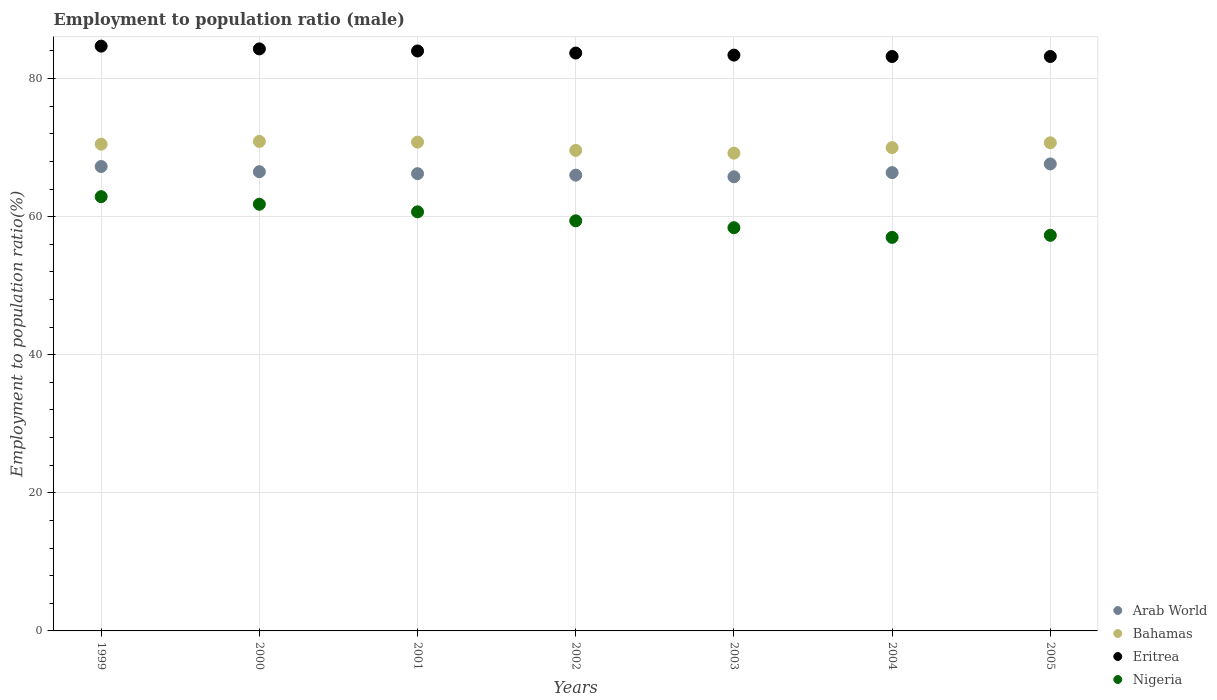Is the number of dotlines equal to the number of legend labels?
Keep it short and to the point. Yes. What is the employment to population ratio in Eritrea in 2002?
Provide a succinct answer. 83.7. Across all years, what is the maximum employment to population ratio in Eritrea?
Your answer should be compact. 84.7. Across all years, what is the minimum employment to population ratio in Arab World?
Provide a succinct answer. 65.78. What is the total employment to population ratio in Bahamas in the graph?
Keep it short and to the point. 491.7. What is the difference between the employment to population ratio in Bahamas in 2000 and that in 2004?
Offer a very short reply. 0.9. What is the difference between the employment to population ratio in Arab World in 2003 and the employment to population ratio in Bahamas in 2005?
Offer a terse response. -4.92. What is the average employment to population ratio in Nigeria per year?
Your response must be concise. 59.64. In the year 2002, what is the difference between the employment to population ratio in Arab World and employment to population ratio in Nigeria?
Your answer should be compact. 6.62. In how many years, is the employment to population ratio in Arab World greater than 48 %?
Provide a short and direct response. 7. What is the ratio of the employment to population ratio in Bahamas in 2001 to that in 2002?
Keep it short and to the point. 1.02. What is the difference between the highest and the second highest employment to population ratio in Arab World?
Provide a short and direct response. 0.37. What is the difference between the highest and the lowest employment to population ratio in Nigeria?
Offer a very short reply. 5.9. In how many years, is the employment to population ratio in Nigeria greater than the average employment to population ratio in Nigeria taken over all years?
Your response must be concise. 3. Is it the case that in every year, the sum of the employment to population ratio in Nigeria and employment to population ratio in Arab World  is greater than the employment to population ratio in Eritrea?
Offer a very short reply. Yes. Is the employment to population ratio in Bahamas strictly less than the employment to population ratio in Nigeria over the years?
Keep it short and to the point. No. How many dotlines are there?
Provide a short and direct response. 4. How many years are there in the graph?
Provide a short and direct response. 7. Where does the legend appear in the graph?
Provide a short and direct response. Bottom right. What is the title of the graph?
Provide a short and direct response. Employment to population ratio (male). Does "Turkey" appear as one of the legend labels in the graph?
Offer a terse response. No. What is the Employment to population ratio(%) of Arab World in 1999?
Your answer should be very brief. 67.26. What is the Employment to population ratio(%) in Bahamas in 1999?
Offer a terse response. 70.5. What is the Employment to population ratio(%) of Eritrea in 1999?
Your answer should be very brief. 84.7. What is the Employment to population ratio(%) in Nigeria in 1999?
Your answer should be compact. 62.9. What is the Employment to population ratio(%) in Arab World in 2000?
Ensure brevity in your answer.  66.51. What is the Employment to population ratio(%) of Bahamas in 2000?
Give a very brief answer. 70.9. What is the Employment to population ratio(%) of Eritrea in 2000?
Make the answer very short. 84.3. What is the Employment to population ratio(%) of Nigeria in 2000?
Offer a very short reply. 61.8. What is the Employment to population ratio(%) of Arab World in 2001?
Your answer should be very brief. 66.23. What is the Employment to population ratio(%) of Bahamas in 2001?
Provide a short and direct response. 70.8. What is the Employment to population ratio(%) of Nigeria in 2001?
Provide a short and direct response. 60.7. What is the Employment to population ratio(%) in Arab World in 2002?
Provide a short and direct response. 66.02. What is the Employment to population ratio(%) of Bahamas in 2002?
Provide a succinct answer. 69.6. What is the Employment to population ratio(%) of Eritrea in 2002?
Provide a short and direct response. 83.7. What is the Employment to population ratio(%) of Nigeria in 2002?
Make the answer very short. 59.4. What is the Employment to population ratio(%) of Arab World in 2003?
Your response must be concise. 65.78. What is the Employment to population ratio(%) in Bahamas in 2003?
Give a very brief answer. 69.2. What is the Employment to population ratio(%) in Eritrea in 2003?
Give a very brief answer. 83.4. What is the Employment to population ratio(%) in Nigeria in 2003?
Your answer should be very brief. 58.4. What is the Employment to population ratio(%) in Arab World in 2004?
Provide a short and direct response. 66.38. What is the Employment to population ratio(%) in Bahamas in 2004?
Keep it short and to the point. 70. What is the Employment to population ratio(%) in Eritrea in 2004?
Your answer should be very brief. 83.2. What is the Employment to population ratio(%) in Nigeria in 2004?
Your answer should be very brief. 57. What is the Employment to population ratio(%) in Arab World in 2005?
Offer a terse response. 67.64. What is the Employment to population ratio(%) in Bahamas in 2005?
Offer a very short reply. 70.7. What is the Employment to population ratio(%) of Eritrea in 2005?
Ensure brevity in your answer.  83.2. What is the Employment to population ratio(%) in Nigeria in 2005?
Offer a terse response. 57.3. Across all years, what is the maximum Employment to population ratio(%) of Arab World?
Provide a succinct answer. 67.64. Across all years, what is the maximum Employment to population ratio(%) in Bahamas?
Your answer should be very brief. 70.9. Across all years, what is the maximum Employment to population ratio(%) in Eritrea?
Ensure brevity in your answer.  84.7. Across all years, what is the maximum Employment to population ratio(%) in Nigeria?
Provide a succinct answer. 62.9. Across all years, what is the minimum Employment to population ratio(%) in Arab World?
Offer a terse response. 65.78. Across all years, what is the minimum Employment to population ratio(%) of Bahamas?
Provide a short and direct response. 69.2. Across all years, what is the minimum Employment to population ratio(%) in Eritrea?
Offer a very short reply. 83.2. Across all years, what is the minimum Employment to population ratio(%) of Nigeria?
Offer a very short reply. 57. What is the total Employment to population ratio(%) of Arab World in the graph?
Offer a very short reply. 465.82. What is the total Employment to population ratio(%) in Bahamas in the graph?
Offer a very short reply. 491.7. What is the total Employment to population ratio(%) in Eritrea in the graph?
Give a very brief answer. 586.5. What is the total Employment to population ratio(%) of Nigeria in the graph?
Your response must be concise. 417.5. What is the difference between the Employment to population ratio(%) of Arab World in 1999 and that in 2000?
Provide a succinct answer. 0.75. What is the difference between the Employment to population ratio(%) in Bahamas in 1999 and that in 2000?
Provide a succinct answer. -0.4. What is the difference between the Employment to population ratio(%) of Nigeria in 1999 and that in 2000?
Your response must be concise. 1.1. What is the difference between the Employment to population ratio(%) in Arab World in 1999 and that in 2001?
Offer a terse response. 1.04. What is the difference between the Employment to population ratio(%) of Bahamas in 1999 and that in 2001?
Make the answer very short. -0.3. What is the difference between the Employment to population ratio(%) of Eritrea in 1999 and that in 2001?
Provide a short and direct response. 0.7. What is the difference between the Employment to population ratio(%) in Nigeria in 1999 and that in 2001?
Offer a very short reply. 2.2. What is the difference between the Employment to population ratio(%) in Arab World in 1999 and that in 2002?
Your answer should be very brief. 1.25. What is the difference between the Employment to population ratio(%) of Arab World in 1999 and that in 2003?
Your response must be concise. 1.49. What is the difference between the Employment to population ratio(%) in Bahamas in 1999 and that in 2003?
Ensure brevity in your answer.  1.3. What is the difference between the Employment to population ratio(%) in Nigeria in 1999 and that in 2003?
Your answer should be very brief. 4.5. What is the difference between the Employment to population ratio(%) of Arab World in 1999 and that in 2004?
Your answer should be very brief. 0.89. What is the difference between the Employment to population ratio(%) in Bahamas in 1999 and that in 2004?
Give a very brief answer. 0.5. What is the difference between the Employment to population ratio(%) of Eritrea in 1999 and that in 2004?
Your response must be concise. 1.5. What is the difference between the Employment to population ratio(%) in Nigeria in 1999 and that in 2004?
Your answer should be very brief. 5.9. What is the difference between the Employment to population ratio(%) of Arab World in 1999 and that in 2005?
Make the answer very short. -0.37. What is the difference between the Employment to population ratio(%) of Bahamas in 1999 and that in 2005?
Your answer should be very brief. -0.2. What is the difference between the Employment to population ratio(%) in Nigeria in 1999 and that in 2005?
Your answer should be very brief. 5.6. What is the difference between the Employment to population ratio(%) of Arab World in 2000 and that in 2001?
Provide a short and direct response. 0.29. What is the difference between the Employment to population ratio(%) of Bahamas in 2000 and that in 2001?
Your answer should be very brief. 0.1. What is the difference between the Employment to population ratio(%) in Nigeria in 2000 and that in 2001?
Provide a short and direct response. 1.1. What is the difference between the Employment to population ratio(%) of Arab World in 2000 and that in 2002?
Give a very brief answer. 0.5. What is the difference between the Employment to population ratio(%) in Nigeria in 2000 and that in 2002?
Ensure brevity in your answer.  2.4. What is the difference between the Employment to population ratio(%) of Arab World in 2000 and that in 2003?
Provide a short and direct response. 0.73. What is the difference between the Employment to population ratio(%) in Bahamas in 2000 and that in 2003?
Keep it short and to the point. 1.7. What is the difference between the Employment to population ratio(%) of Nigeria in 2000 and that in 2003?
Make the answer very short. 3.4. What is the difference between the Employment to population ratio(%) in Arab World in 2000 and that in 2004?
Provide a succinct answer. 0.13. What is the difference between the Employment to population ratio(%) in Nigeria in 2000 and that in 2004?
Give a very brief answer. 4.8. What is the difference between the Employment to population ratio(%) of Arab World in 2000 and that in 2005?
Your response must be concise. -1.12. What is the difference between the Employment to population ratio(%) in Bahamas in 2000 and that in 2005?
Offer a very short reply. 0.2. What is the difference between the Employment to population ratio(%) in Eritrea in 2000 and that in 2005?
Your response must be concise. 1.1. What is the difference between the Employment to population ratio(%) of Arab World in 2001 and that in 2002?
Offer a terse response. 0.21. What is the difference between the Employment to population ratio(%) in Bahamas in 2001 and that in 2002?
Provide a succinct answer. 1.2. What is the difference between the Employment to population ratio(%) of Nigeria in 2001 and that in 2002?
Your answer should be very brief. 1.3. What is the difference between the Employment to population ratio(%) of Arab World in 2001 and that in 2003?
Offer a terse response. 0.45. What is the difference between the Employment to population ratio(%) of Bahamas in 2001 and that in 2003?
Keep it short and to the point. 1.6. What is the difference between the Employment to population ratio(%) of Nigeria in 2001 and that in 2003?
Make the answer very short. 2.3. What is the difference between the Employment to population ratio(%) in Arab World in 2001 and that in 2004?
Your answer should be very brief. -0.15. What is the difference between the Employment to population ratio(%) of Bahamas in 2001 and that in 2004?
Keep it short and to the point. 0.8. What is the difference between the Employment to population ratio(%) in Nigeria in 2001 and that in 2004?
Make the answer very short. 3.7. What is the difference between the Employment to population ratio(%) in Arab World in 2001 and that in 2005?
Your response must be concise. -1.41. What is the difference between the Employment to population ratio(%) of Eritrea in 2001 and that in 2005?
Provide a short and direct response. 0.8. What is the difference between the Employment to population ratio(%) in Arab World in 2002 and that in 2003?
Provide a succinct answer. 0.24. What is the difference between the Employment to population ratio(%) in Eritrea in 2002 and that in 2003?
Give a very brief answer. 0.3. What is the difference between the Employment to population ratio(%) in Arab World in 2002 and that in 2004?
Ensure brevity in your answer.  -0.36. What is the difference between the Employment to population ratio(%) of Bahamas in 2002 and that in 2004?
Offer a very short reply. -0.4. What is the difference between the Employment to population ratio(%) in Nigeria in 2002 and that in 2004?
Make the answer very short. 2.4. What is the difference between the Employment to population ratio(%) in Arab World in 2002 and that in 2005?
Offer a terse response. -1.62. What is the difference between the Employment to population ratio(%) in Arab World in 2003 and that in 2004?
Provide a short and direct response. -0.6. What is the difference between the Employment to population ratio(%) in Arab World in 2003 and that in 2005?
Your answer should be compact. -1.86. What is the difference between the Employment to population ratio(%) in Eritrea in 2003 and that in 2005?
Ensure brevity in your answer.  0.2. What is the difference between the Employment to population ratio(%) in Arab World in 2004 and that in 2005?
Make the answer very short. -1.26. What is the difference between the Employment to population ratio(%) in Eritrea in 2004 and that in 2005?
Give a very brief answer. 0. What is the difference between the Employment to population ratio(%) of Nigeria in 2004 and that in 2005?
Provide a succinct answer. -0.3. What is the difference between the Employment to population ratio(%) of Arab World in 1999 and the Employment to population ratio(%) of Bahamas in 2000?
Your response must be concise. -3.64. What is the difference between the Employment to population ratio(%) of Arab World in 1999 and the Employment to population ratio(%) of Eritrea in 2000?
Your response must be concise. -17.04. What is the difference between the Employment to population ratio(%) in Arab World in 1999 and the Employment to population ratio(%) in Nigeria in 2000?
Provide a succinct answer. 5.46. What is the difference between the Employment to population ratio(%) of Bahamas in 1999 and the Employment to population ratio(%) of Nigeria in 2000?
Ensure brevity in your answer.  8.7. What is the difference between the Employment to population ratio(%) in Eritrea in 1999 and the Employment to population ratio(%) in Nigeria in 2000?
Make the answer very short. 22.9. What is the difference between the Employment to population ratio(%) in Arab World in 1999 and the Employment to population ratio(%) in Bahamas in 2001?
Your answer should be very brief. -3.54. What is the difference between the Employment to population ratio(%) of Arab World in 1999 and the Employment to population ratio(%) of Eritrea in 2001?
Give a very brief answer. -16.74. What is the difference between the Employment to population ratio(%) in Arab World in 1999 and the Employment to population ratio(%) in Nigeria in 2001?
Your answer should be compact. 6.56. What is the difference between the Employment to population ratio(%) in Bahamas in 1999 and the Employment to population ratio(%) in Nigeria in 2001?
Offer a terse response. 9.8. What is the difference between the Employment to population ratio(%) in Arab World in 1999 and the Employment to population ratio(%) in Bahamas in 2002?
Offer a terse response. -2.34. What is the difference between the Employment to population ratio(%) in Arab World in 1999 and the Employment to population ratio(%) in Eritrea in 2002?
Provide a succinct answer. -16.44. What is the difference between the Employment to population ratio(%) in Arab World in 1999 and the Employment to population ratio(%) in Nigeria in 2002?
Keep it short and to the point. 7.86. What is the difference between the Employment to population ratio(%) in Bahamas in 1999 and the Employment to population ratio(%) in Nigeria in 2002?
Offer a terse response. 11.1. What is the difference between the Employment to population ratio(%) of Eritrea in 1999 and the Employment to population ratio(%) of Nigeria in 2002?
Give a very brief answer. 25.3. What is the difference between the Employment to population ratio(%) of Arab World in 1999 and the Employment to population ratio(%) of Bahamas in 2003?
Make the answer very short. -1.94. What is the difference between the Employment to population ratio(%) of Arab World in 1999 and the Employment to population ratio(%) of Eritrea in 2003?
Keep it short and to the point. -16.14. What is the difference between the Employment to population ratio(%) in Arab World in 1999 and the Employment to population ratio(%) in Nigeria in 2003?
Offer a very short reply. 8.86. What is the difference between the Employment to population ratio(%) in Eritrea in 1999 and the Employment to population ratio(%) in Nigeria in 2003?
Provide a succinct answer. 26.3. What is the difference between the Employment to population ratio(%) in Arab World in 1999 and the Employment to population ratio(%) in Bahamas in 2004?
Your response must be concise. -2.74. What is the difference between the Employment to population ratio(%) of Arab World in 1999 and the Employment to population ratio(%) of Eritrea in 2004?
Your response must be concise. -15.94. What is the difference between the Employment to population ratio(%) in Arab World in 1999 and the Employment to population ratio(%) in Nigeria in 2004?
Your response must be concise. 10.26. What is the difference between the Employment to population ratio(%) of Bahamas in 1999 and the Employment to population ratio(%) of Eritrea in 2004?
Offer a terse response. -12.7. What is the difference between the Employment to population ratio(%) in Bahamas in 1999 and the Employment to population ratio(%) in Nigeria in 2004?
Your answer should be compact. 13.5. What is the difference between the Employment to population ratio(%) in Eritrea in 1999 and the Employment to population ratio(%) in Nigeria in 2004?
Your response must be concise. 27.7. What is the difference between the Employment to population ratio(%) in Arab World in 1999 and the Employment to population ratio(%) in Bahamas in 2005?
Ensure brevity in your answer.  -3.44. What is the difference between the Employment to population ratio(%) in Arab World in 1999 and the Employment to population ratio(%) in Eritrea in 2005?
Keep it short and to the point. -15.94. What is the difference between the Employment to population ratio(%) of Arab World in 1999 and the Employment to population ratio(%) of Nigeria in 2005?
Provide a succinct answer. 9.96. What is the difference between the Employment to population ratio(%) in Bahamas in 1999 and the Employment to population ratio(%) in Eritrea in 2005?
Give a very brief answer. -12.7. What is the difference between the Employment to population ratio(%) of Bahamas in 1999 and the Employment to population ratio(%) of Nigeria in 2005?
Keep it short and to the point. 13.2. What is the difference between the Employment to population ratio(%) of Eritrea in 1999 and the Employment to population ratio(%) of Nigeria in 2005?
Keep it short and to the point. 27.4. What is the difference between the Employment to population ratio(%) in Arab World in 2000 and the Employment to population ratio(%) in Bahamas in 2001?
Keep it short and to the point. -4.29. What is the difference between the Employment to population ratio(%) of Arab World in 2000 and the Employment to population ratio(%) of Eritrea in 2001?
Provide a succinct answer. -17.49. What is the difference between the Employment to population ratio(%) of Arab World in 2000 and the Employment to population ratio(%) of Nigeria in 2001?
Your answer should be compact. 5.81. What is the difference between the Employment to population ratio(%) of Bahamas in 2000 and the Employment to population ratio(%) of Nigeria in 2001?
Provide a short and direct response. 10.2. What is the difference between the Employment to population ratio(%) in Eritrea in 2000 and the Employment to population ratio(%) in Nigeria in 2001?
Give a very brief answer. 23.6. What is the difference between the Employment to population ratio(%) of Arab World in 2000 and the Employment to population ratio(%) of Bahamas in 2002?
Keep it short and to the point. -3.09. What is the difference between the Employment to population ratio(%) in Arab World in 2000 and the Employment to population ratio(%) in Eritrea in 2002?
Your response must be concise. -17.19. What is the difference between the Employment to population ratio(%) of Arab World in 2000 and the Employment to population ratio(%) of Nigeria in 2002?
Your response must be concise. 7.11. What is the difference between the Employment to population ratio(%) of Eritrea in 2000 and the Employment to population ratio(%) of Nigeria in 2002?
Provide a short and direct response. 24.9. What is the difference between the Employment to population ratio(%) in Arab World in 2000 and the Employment to population ratio(%) in Bahamas in 2003?
Provide a succinct answer. -2.69. What is the difference between the Employment to population ratio(%) in Arab World in 2000 and the Employment to population ratio(%) in Eritrea in 2003?
Offer a terse response. -16.89. What is the difference between the Employment to population ratio(%) in Arab World in 2000 and the Employment to population ratio(%) in Nigeria in 2003?
Offer a very short reply. 8.11. What is the difference between the Employment to population ratio(%) in Eritrea in 2000 and the Employment to population ratio(%) in Nigeria in 2003?
Your answer should be compact. 25.9. What is the difference between the Employment to population ratio(%) of Arab World in 2000 and the Employment to population ratio(%) of Bahamas in 2004?
Your response must be concise. -3.49. What is the difference between the Employment to population ratio(%) of Arab World in 2000 and the Employment to population ratio(%) of Eritrea in 2004?
Provide a short and direct response. -16.69. What is the difference between the Employment to population ratio(%) of Arab World in 2000 and the Employment to population ratio(%) of Nigeria in 2004?
Keep it short and to the point. 9.51. What is the difference between the Employment to population ratio(%) of Bahamas in 2000 and the Employment to population ratio(%) of Nigeria in 2004?
Provide a short and direct response. 13.9. What is the difference between the Employment to population ratio(%) of Eritrea in 2000 and the Employment to population ratio(%) of Nigeria in 2004?
Provide a short and direct response. 27.3. What is the difference between the Employment to population ratio(%) of Arab World in 2000 and the Employment to population ratio(%) of Bahamas in 2005?
Offer a terse response. -4.19. What is the difference between the Employment to population ratio(%) in Arab World in 2000 and the Employment to population ratio(%) in Eritrea in 2005?
Provide a succinct answer. -16.69. What is the difference between the Employment to population ratio(%) of Arab World in 2000 and the Employment to population ratio(%) of Nigeria in 2005?
Keep it short and to the point. 9.21. What is the difference between the Employment to population ratio(%) of Eritrea in 2000 and the Employment to population ratio(%) of Nigeria in 2005?
Your answer should be compact. 27. What is the difference between the Employment to population ratio(%) in Arab World in 2001 and the Employment to population ratio(%) in Bahamas in 2002?
Offer a terse response. -3.37. What is the difference between the Employment to population ratio(%) in Arab World in 2001 and the Employment to population ratio(%) in Eritrea in 2002?
Ensure brevity in your answer.  -17.47. What is the difference between the Employment to population ratio(%) of Arab World in 2001 and the Employment to population ratio(%) of Nigeria in 2002?
Offer a terse response. 6.83. What is the difference between the Employment to population ratio(%) of Bahamas in 2001 and the Employment to population ratio(%) of Eritrea in 2002?
Provide a short and direct response. -12.9. What is the difference between the Employment to population ratio(%) in Eritrea in 2001 and the Employment to population ratio(%) in Nigeria in 2002?
Your answer should be compact. 24.6. What is the difference between the Employment to population ratio(%) of Arab World in 2001 and the Employment to population ratio(%) of Bahamas in 2003?
Make the answer very short. -2.97. What is the difference between the Employment to population ratio(%) in Arab World in 2001 and the Employment to population ratio(%) in Eritrea in 2003?
Your answer should be very brief. -17.17. What is the difference between the Employment to population ratio(%) of Arab World in 2001 and the Employment to population ratio(%) of Nigeria in 2003?
Offer a very short reply. 7.83. What is the difference between the Employment to population ratio(%) of Eritrea in 2001 and the Employment to population ratio(%) of Nigeria in 2003?
Give a very brief answer. 25.6. What is the difference between the Employment to population ratio(%) of Arab World in 2001 and the Employment to population ratio(%) of Bahamas in 2004?
Your response must be concise. -3.77. What is the difference between the Employment to population ratio(%) in Arab World in 2001 and the Employment to population ratio(%) in Eritrea in 2004?
Make the answer very short. -16.97. What is the difference between the Employment to population ratio(%) of Arab World in 2001 and the Employment to population ratio(%) of Nigeria in 2004?
Offer a very short reply. 9.23. What is the difference between the Employment to population ratio(%) in Eritrea in 2001 and the Employment to population ratio(%) in Nigeria in 2004?
Offer a very short reply. 27. What is the difference between the Employment to population ratio(%) of Arab World in 2001 and the Employment to population ratio(%) of Bahamas in 2005?
Keep it short and to the point. -4.47. What is the difference between the Employment to population ratio(%) of Arab World in 2001 and the Employment to population ratio(%) of Eritrea in 2005?
Give a very brief answer. -16.97. What is the difference between the Employment to population ratio(%) of Arab World in 2001 and the Employment to population ratio(%) of Nigeria in 2005?
Make the answer very short. 8.93. What is the difference between the Employment to population ratio(%) in Bahamas in 2001 and the Employment to population ratio(%) in Eritrea in 2005?
Your answer should be very brief. -12.4. What is the difference between the Employment to population ratio(%) in Bahamas in 2001 and the Employment to population ratio(%) in Nigeria in 2005?
Offer a terse response. 13.5. What is the difference between the Employment to population ratio(%) in Eritrea in 2001 and the Employment to population ratio(%) in Nigeria in 2005?
Your answer should be very brief. 26.7. What is the difference between the Employment to population ratio(%) in Arab World in 2002 and the Employment to population ratio(%) in Bahamas in 2003?
Provide a succinct answer. -3.19. What is the difference between the Employment to population ratio(%) in Arab World in 2002 and the Employment to population ratio(%) in Eritrea in 2003?
Keep it short and to the point. -17.39. What is the difference between the Employment to population ratio(%) of Arab World in 2002 and the Employment to population ratio(%) of Nigeria in 2003?
Your answer should be very brief. 7.62. What is the difference between the Employment to population ratio(%) of Eritrea in 2002 and the Employment to population ratio(%) of Nigeria in 2003?
Ensure brevity in your answer.  25.3. What is the difference between the Employment to population ratio(%) of Arab World in 2002 and the Employment to population ratio(%) of Bahamas in 2004?
Keep it short and to the point. -3.98. What is the difference between the Employment to population ratio(%) in Arab World in 2002 and the Employment to population ratio(%) in Eritrea in 2004?
Make the answer very short. -17.18. What is the difference between the Employment to population ratio(%) in Arab World in 2002 and the Employment to population ratio(%) in Nigeria in 2004?
Your answer should be very brief. 9.02. What is the difference between the Employment to population ratio(%) in Bahamas in 2002 and the Employment to population ratio(%) in Eritrea in 2004?
Provide a succinct answer. -13.6. What is the difference between the Employment to population ratio(%) of Bahamas in 2002 and the Employment to population ratio(%) of Nigeria in 2004?
Provide a short and direct response. 12.6. What is the difference between the Employment to population ratio(%) in Eritrea in 2002 and the Employment to population ratio(%) in Nigeria in 2004?
Give a very brief answer. 26.7. What is the difference between the Employment to population ratio(%) of Arab World in 2002 and the Employment to population ratio(%) of Bahamas in 2005?
Your response must be concise. -4.68. What is the difference between the Employment to population ratio(%) of Arab World in 2002 and the Employment to population ratio(%) of Eritrea in 2005?
Offer a terse response. -17.18. What is the difference between the Employment to population ratio(%) in Arab World in 2002 and the Employment to population ratio(%) in Nigeria in 2005?
Make the answer very short. 8.71. What is the difference between the Employment to population ratio(%) of Bahamas in 2002 and the Employment to population ratio(%) of Eritrea in 2005?
Provide a short and direct response. -13.6. What is the difference between the Employment to population ratio(%) in Bahamas in 2002 and the Employment to population ratio(%) in Nigeria in 2005?
Provide a short and direct response. 12.3. What is the difference between the Employment to population ratio(%) in Eritrea in 2002 and the Employment to population ratio(%) in Nigeria in 2005?
Offer a terse response. 26.4. What is the difference between the Employment to population ratio(%) of Arab World in 2003 and the Employment to population ratio(%) of Bahamas in 2004?
Keep it short and to the point. -4.22. What is the difference between the Employment to population ratio(%) of Arab World in 2003 and the Employment to population ratio(%) of Eritrea in 2004?
Your answer should be very brief. -17.42. What is the difference between the Employment to population ratio(%) in Arab World in 2003 and the Employment to population ratio(%) in Nigeria in 2004?
Give a very brief answer. 8.78. What is the difference between the Employment to population ratio(%) of Bahamas in 2003 and the Employment to population ratio(%) of Nigeria in 2004?
Make the answer very short. 12.2. What is the difference between the Employment to population ratio(%) in Eritrea in 2003 and the Employment to population ratio(%) in Nigeria in 2004?
Your answer should be very brief. 26.4. What is the difference between the Employment to population ratio(%) of Arab World in 2003 and the Employment to population ratio(%) of Bahamas in 2005?
Make the answer very short. -4.92. What is the difference between the Employment to population ratio(%) of Arab World in 2003 and the Employment to population ratio(%) of Eritrea in 2005?
Offer a terse response. -17.42. What is the difference between the Employment to population ratio(%) of Arab World in 2003 and the Employment to population ratio(%) of Nigeria in 2005?
Your response must be concise. 8.48. What is the difference between the Employment to population ratio(%) of Bahamas in 2003 and the Employment to population ratio(%) of Eritrea in 2005?
Keep it short and to the point. -14. What is the difference between the Employment to population ratio(%) in Bahamas in 2003 and the Employment to population ratio(%) in Nigeria in 2005?
Make the answer very short. 11.9. What is the difference between the Employment to population ratio(%) in Eritrea in 2003 and the Employment to population ratio(%) in Nigeria in 2005?
Your answer should be very brief. 26.1. What is the difference between the Employment to population ratio(%) in Arab World in 2004 and the Employment to population ratio(%) in Bahamas in 2005?
Offer a terse response. -4.32. What is the difference between the Employment to population ratio(%) in Arab World in 2004 and the Employment to population ratio(%) in Eritrea in 2005?
Your answer should be compact. -16.82. What is the difference between the Employment to population ratio(%) of Arab World in 2004 and the Employment to population ratio(%) of Nigeria in 2005?
Keep it short and to the point. 9.08. What is the difference between the Employment to population ratio(%) in Bahamas in 2004 and the Employment to population ratio(%) in Nigeria in 2005?
Offer a very short reply. 12.7. What is the difference between the Employment to population ratio(%) in Eritrea in 2004 and the Employment to population ratio(%) in Nigeria in 2005?
Provide a succinct answer. 25.9. What is the average Employment to population ratio(%) in Arab World per year?
Give a very brief answer. 66.55. What is the average Employment to population ratio(%) in Bahamas per year?
Keep it short and to the point. 70.24. What is the average Employment to population ratio(%) in Eritrea per year?
Your answer should be compact. 83.79. What is the average Employment to population ratio(%) in Nigeria per year?
Offer a very short reply. 59.64. In the year 1999, what is the difference between the Employment to population ratio(%) of Arab World and Employment to population ratio(%) of Bahamas?
Ensure brevity in your answer.  -3.24. In the year 1999, what is the difference between the Employment to population ratio(%) of Arab World and Employment to population ratio(%) of Eritrea?
Your answer should be very brief. -17.44. In the year 1999, what is the difference between the Employment to population ratio(%) of Arab World and Employment to population ratio(%) of Nigeria?
Provide a succinct answer. 4.36. In the year 1999, what is the difference between the Employment to population ratio(%) of Bahamas and Employment to population ratio(%) of Nigeria?
Your answer should be very brief. 7.6. In the year 1999, what is the difference between the Employment to population ratio(%) of Eritrea and Employment to population ratio(%) of Nigeria?
Keep it short and to the point. 21.8. In the year 2000, what is the difference between the Employment to population ratio(%) of Arab World and Employment to population ratio(%) of Bahamas?
Give a very brief answer. -4.39. In the year 2000, what is the difference between the Employment to population ratio(%) in Arab World and Employment to population ratio(%) in Eritrea?
Ensure brevity in your answer.  -17.79. In the year 2000, what is the difference between the Employment to population ratio(%) of Arab World and Employment to population ratio(%) of Nigeria?
Ensure brevity in your answer.  4.71. In the year 2000, what is the difference between the Employment to population ratio(%) in Bahamas and Employment to population ratio(%) in Nigeria?
Ensure brevity in your answer.  9.1. In the year 2000, what is the difference between the Employment to population ratio(%) of Eritrea and Employment to population ratio(%) of Nigeria?
Your answer should be compact. 22.5. In the year 2001, what is the difference between the Employment to population ratio(%) in Arab World and Employment to population ratio(%) in Bahamas?
Give a very brief answer. -4.57. In the year 2001, what is the difference between the Employment to population ratio(%) of Arab World and Employment to population ratio(%) of Eritrea?
Provide a short and direct response. -17.77. In the year 2001, what is the difference between the Employment to population ratio(%) in Arab World and Employment to population ratio(%) in Nigeria?
Your answer should be very brief. 5.53. In the year 2001, what is the difference between the Employment to population ratio(%) of Eritrea and Employment to population ratio(%) of Nigeria?
Your answer should be very brief. 23.3. In the year 2002, what is the difference between the Employment to population ratio(%) in Arab World and Employment to population ratio(%) in Bahamas?
Provide a short and direct response. -3.58. In the year 2002, what is the difference between the Employment to population ratio(%) of Arab World and Employment to population ratio(%) of Eritrea?
Give a very brief answer. -17.68. In the year 2002, what is the difference between the Employment to population ratio(%) of Arab World and Employment to population ratio(%) of Nigeria?
Your answer should be compact. 6.62. In the year 2002, what is the difference between the Employment to population ratio(%) of Bahamas and Employment to population ratio(%) of Eritrea?
Provide a short and direct response. -14.1. In the year 2002, what is the difference between the Employment to population ratio(%) in Eritrea and Employment to population ratio(%) in Nigeria?
Give a very brief answer. 24.3. In the year 2003, what is the difference between the Employment to population ratio(%) of Arab World and Employment to population ratio(%) of Bahamas?
Give a very brief answer. -3.42. In the year 2003, what is the difference between the Employment to population ratio(%) of Arab World and Employment to population ratio(%) of Eritrea?
Provide a short and direct response. -17.62. In the year 2003, what is the difference between the Employment to population ratio(%) in Arab World and Employment to population ratio(%) in Nigeria?
Give a very brief answer. 7.38. In the year 2003, what is the difference between the Employment to population ratio(%) of Bahamas and Employment to population ratio(%) of Eritrea?
Ensure brevity in your answer.  -14.2. In the year 2004, what is the difference between the Employment to population ratio(%) in Arab World and Employment to population ratio(%) in Bahamas?
Your answer should be very brief. -3.62. In the year 2004, what is the difference between the Employment to population ratio(%) of Arab World and Employment to population ratio(%) of Eritrea?
Offer a very short reply. -16.82. In the year 2004, what is the difference between the Employment to population ratio(%) in Arab World and Employment to population ratio(%) in Nigeria?
Your response must be concise. 9.38. In the year 2004, what is the difference between the Employment to population ratio(%) in Bahamas and Employment to population ratio(%) in Eritrea?
Provide a succinct answer. -13.2. In the year 2004, what is the difference between the Employment to population ratio(%) in Bahamas and Employment to population ratio(%) in Nigeria?
Your answer should be compact. 13. In the year 2004, what is the difference between the Employment to population ratio(%) in Eritrea and Employment to population ratio(%) in Nigeria?
Offer a very short reply. 26.2. In the year 2005, what is the difference between the Employment to population ratio(%) in Arab World and Employment to population ratio(%) in Bahamas?
Offer a very short reply. -3.06. In the year 2005, what is the difference between the Employment to population ratio(%) of Arab World and Employment to population ratio(%) of Eritrea?
Offer a very short reply. -15.56. In the year 2005, what is the difference between the Employment to population ratio(%) in Arab World and Employment to population ratio(%) in Nigeria?
Provide a short and direct response. 10.34. In the year 2005, what is the difference between the Employment to population ratio(%) of Bahamas and Employment to population ratio(%) of Eritrea?
Keep it short and to the point. -12.5. In the year 2005, what is the difference between the Employment to population ratio(%) in Bahamas and Employment to population ratio(%) in Nigeria?
Provide a succinct answer. 13.4. In the year 2005, what is the difference between the Employment to population ratio(%) of Eritrea and Employment to population ratio(%) of Nigeria?
Give a very brief answer. 25.9. What is the ratio of the Employment to population ratio(%) of Arab World in 1999 to that in 2000?
Your response must be concise. 1.01. What is the ratio of the Employment to population ratio(%) of Eritrea in 1999 to that in 2000?
Your response must be concise. 1. What is the ratio of the Employment to population ratio(%) in Nigeria in 1999 to that in 2000?
Give a very brief answer. 1.02. What is the ratio of the Employment to population ratio(%) in Arab World in 1999 to that in 2001?
Give a very brief answer. 1.02. What is the ratio of the Employment to population ratio(%) in Bahamas in 1999 to that in 2001?
Offer a very short reply. 1. What is the ratio of the Employment to population ratio(%) of Eritrea in 1999 to that in 2001?
Offer a terse response. 1.01. What is the ratio of the Employment to population ratio(%) of Nigeria in 1999 to that in 2001?
Provide a succinct answer. 1.04. What is the ratio of the Employment to population ratio(%) of Arab World in 1999 to that in 2002?
Your response must be concise. 1.02. What is the ratio of the Employment to population ratio(%) in Bahamas in 1999 to that in 2002?
Ensure brevity in your answer.  1.01. What is the ratio of the Employment to population ratio(%) of Eritrea in 1999 to that in 2002?
Your answer should be very brief. 1.01. What is the ratio of the Employment to population ratio(%) in Nigeria in 1999 to that in 2002?
Provide a short and direct response. 1.06. What is the ratio of the Employment to population ratio(%) of Arab World in 1999 to that in 2003?
Provide a short and direct response. 1.02. What is the ratio of the Employment to population ratio(%) in Bahamas in 1999 to that in 2003?
Give a very brief answer. 1.02. What is the ratio of the Employment to population ratio(%) in Eritrea in 1999 to that in 2003?
Your response must be concise. 1.02. What is the ratio of the Employment to population ratio(%) in Nigeria in 1999 to that in 2003?
Your answer should be compact. 1.08. What is the ratio of the Employment to population ratio(%) in Arab World in 1999 to that in 2004?
Make the answer very short. 1.01. What is the ratio of the Employment to population ratio(%) in Bahamas in 1999 to that in 2004?
Offer a terse response. 1.01. What is the ratio of the Employment to population ratio(%) of Nigeria in 1999 to that in 2004?
Ensure brevity in your answer.  1.1. What is the ratio of the Employment to population ratio(%) in Bahamas in 1999 to that in 2005?
Offer a terse response. 1. What is the ratio of the Employment to population ratio(%) of Nigeria in 1999 to that in 2005?
Keep it short and to the point. 1.1. What is the ratio of the Employment to population ratio(%) of Arab World in 2000 to that in 2001?
Offer a very short reply. 1. What is the ratio of the Employment to population ratio(%) of Bahamas in 2000 to that in 2001?
Your answer should be very brief. 1. What is the ratio of the Employment to population ratio(%) in Nigeria in 2000 to that in 2001?
Your answer should be compact. 1.02. What is the ratio of the Employment to population ratio(%) of Arab World in 2000 to that in 2002?
Keep it short and to the point. 1.01. What is the ratio of the Employment to population ratio(%) in Bahamas in 2000 to that in 2002?
Provide a short and direct response. 1.02. What is the ratio of the Employment to population ratio(%) of Nigeria in 2000 to that in 2002?
Give a very brief answer. 1.04. What is the ratio of the Employment to population ratio(%) of Arab World in 2000 to that in 2003?
Your answer should be compact. 1.01. What is the ratio of the Employment to population ratio(%) in Bahamas in 2000 to that in 2003?
Your response must be concise. 1.02. What is the ratio of the Employment to population ratio(%) in Eritrea in 2000 to that in 2003?
Keep it short and to the point. 1.01. What is the ratio of the Employment to population ratio(%) of Nigeria in 2000 to that in 2003?
Your response must be concise. 1.06. What is the ratio of the Employment to population ratio(%) of Arab World in 2000 to that in 2004?
Offer a terse response. 1. What is the ratio of the Employment to population ratio(%) in Bahamas in 2000 to that in 2004?
Make the answer very short. 1.01. What is the ratio of the Employment to population ratio(%) in Eritrea in 2000 to that in 2004?
Your response must be concise. 1.01. What is the ratio of the Employment to population ratio(%) of Nigeria in 2000 to that in 2004?
Offer a very short reply. 1.08. What is the ratio of the Employment to population ratio(%) of Arab World in 2000 to that in 2005?
Offer a very short reply. 0.98. What is the ratio of the Employment to population ratio(%) in Eritrea in 2000 to that in 2005?
Provide a succinct answer. 1.01. What is the ratio of the Employment to population ratio(%) of Nigeria in 2000 to that in 2005?
Your response must be concise. 1.08. What is the ratio of the Employment to population ratio(%) of Arab World in 2001 to that in 2002?
Give a very brief answer. 1. What is the ratio of the Employment to population ratio(%) in Bahamas in 2001 to that in 2002?
Your answer should be compact. 1.02. What is the ratio of the Employment to population ratio(%) of Nigeria in 2001 to that in 2002?
Make the answer very short. 1.02. What is the ratio of the Employment to population ratio(%) of Arab World in 2001 to that in 2003?
Your answer should be compact. 1.01. What is the ratio of the Employment to population ratio(%) in Bahamas in 2001 to that in 2003?
Offer a terse response. 1.02. What is the ratio of the Employment to population ratio(%) of Nigeria in 2001 to that in 2003?
Your answer should be compact. 1.04. What is the ratio of the Employment to population ratio(%) of Bahamas in 2001 to that in 2004?
Your answer should be very brief. 1.01. What is the ratio of the Employment to population ratio(%) of Eritrea in 2001 to that in 2004?
Ensure brevity in your answer.  1.01. What is the ratio of the Employment to population ratio(%) in Nigeria in 2001 to that in 2004?
Give a very brief answer. 1.06. What is the ratio of the Employment to population ratio(%) of Arab World in 2001 to that in 2005?
Ensure brevity in your answer.  0.98. What is the ratio of the Employment to population ratio(%) of Eritrea in 2001 to that in 2005?
Ensure brevity in your answer.  1.01. What is the ratio of the Employment to population ratio(%) in Nigeria in 2001 to that in 2005?
Your answer should be compact. 1.06. What is the ratio of the Employment to population ratio(%) in Bahamas in 2002 to that in 2003?
Provide a succinct answer. 1.01. What is the ratio of the Employment to population ratio(%) of Nigeria in 2002 to that in 2003?
Offer a terse response. 1.02. What is the ratio of the Employment to population ratio(%) of Bahamas in 2002 to that in 2004?
Offer a very short reply. 0.99. What is the ratio of the Employment to population ratio(%) of Nigeria in 2002 to that in 2004?
Your answer should be very brief. 1.04. What is the ratio of the Employment to population ratio(%) in Arab World in 2002 to that in 2005?
Ensure brevity in your answer.  0.98. What is the ratio of the Employment to population ratio(%) in Bahamas in 2002 to that in 2005?
Your answer should be compact. 0.98. What is the ratio of the Employment to population ratio(%) in Eritrea in 2002 to that in 2005?
Your response must be concise. 1.01. What is the ratio of the Employment to population ratio(%) of Nigeria in 2002 to that in 2005?
Offer a terse response. 1.04. What is the ratio of the Employment to population ratio(%) of Arab World in 2003 to that in 2004?
Your answer should be very brief. 0.99. What is the ratio of the Employment to population ratio(%) in Eritrea in 2003 to that in 2004?
Keep it short and to the point. 1. What is the ratio of the Employment to population ratio(%) of Nigeria in 2003 to that in 2004?
Provide a succinct answer. 1.02. What is the ratio of the Employment to population ratio(%) of Arab World in 2003 to that in 2005?
Offer a terse response. 0.97. What is the ratio of the Employment to population ratio(%) of Bahamas in 2003 to that in 2005?
Offer a terse response. 0.98. What is the ratio of the Employment to population ratio(%) of Nigeria in 2003 to that in 2005?
Offer a terse response. 1.02. What is the ratio of the Employment to population ratio(%) in Arab World in 2004 to that in 2005?
Offer a terse response. 0.98. What is the ratio of the Employment to population ratio(%) of Bahamas in 2004 to that in 2005?
Provide a succinct answer. 0.99. What is the ratio of the Employment to population ratio(%) in Eritrea in 2004 to that in 2005?
Make the answer very short. 1. What is the ratio of the Employment to population ratio(%) in Nigeria in 2004 to that in 2005?
Ensure brevity in your answer.  0.99. What is the difference between the highest and the second highest Employment to population ratio(%) in Arab World?
Make the answer very short. 0.37. What is the difference between the highest and the second highest Employment to population ratio(%) of Nigeria?
Your answer should be very brief. 1.1. What is the difference between the highest and the lowest Employment to population ratio(%) in Arab World?
Your answer should be very brief. 1.86. What is the difference between the highest and the lowest Employment to population ratio(%) in Bahamas?
Your response must be concise. 1.7. 